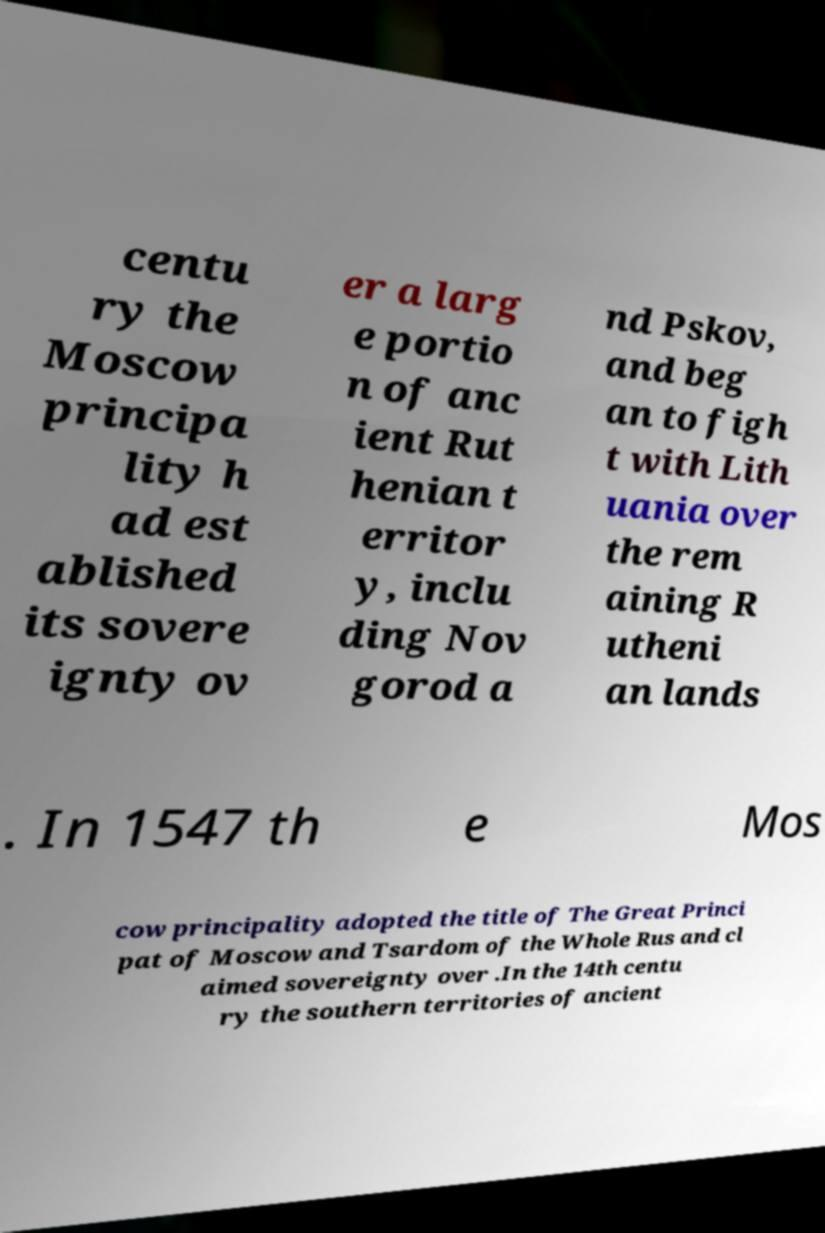What messages or text are displayed in this image? I need them in a readable, typed format. centu ry the Moscow principa lity h ad est ablished its sovere ignty ov er a larg e portio n of anc ient Rut henian t erritor y, inclu ding Nov gorod a nd Pskov, and beg an to figh t with Lith uania over the rem aining R utheni an lands . In 1547 th e Mos cow principality adopted the title of The Great Princi pat of Moscow and Tsardom of the Whole Rus and cl aimed sovereignty over .In the 14th centu ry the southern territories of ancient 